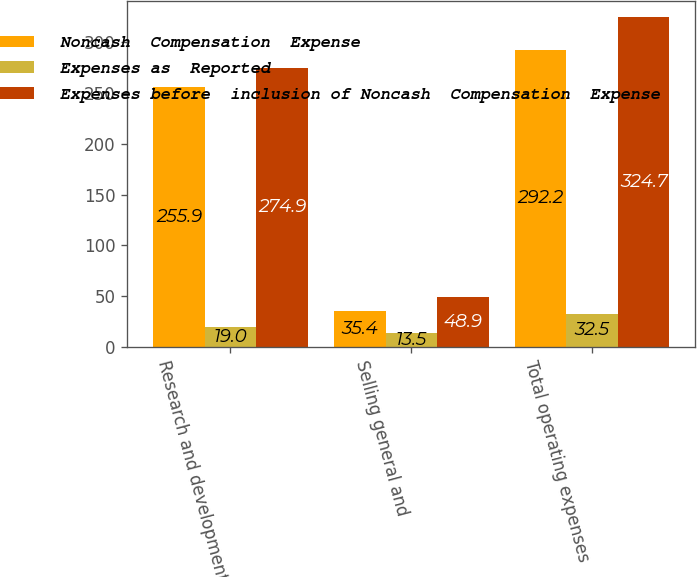Convert chart. <chart><loc_0><loc_0><loc_500><loc_500><stacked_bar_chart><ecel><fcel>Research and development<fcel>Selling general and<fcel>Total operating expenses<nl><fcel>Noncash  Compensation  Expense<fcel>255.9<fcel>35.4<fcel>292.2<nl><fcel>Expenses as  Reported<fcel>19<fcel>13.5<fcel>32.5<nl><fcel>Expenses before  inclusion of Noncash  Compensation  Expense<fcel>274.9<fcel>48.9<fcel>324.7<nl></chart> 